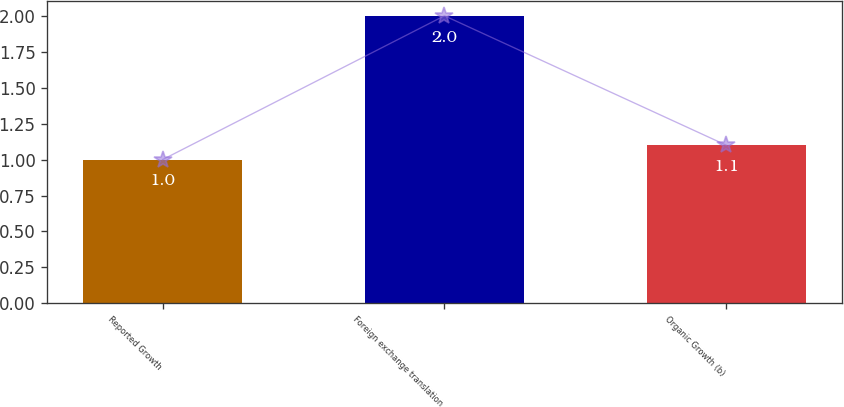Convert chart to OTSL. <chart><loc_0><loc_0><loc_500><loc_500><bar_chart><fcel>Reported Growth<fcel>Foreign exchange translation<fcel>Organic Growth (b)<nl><fcel>1<fcel>2<fcel>1.1<nl></chart> 